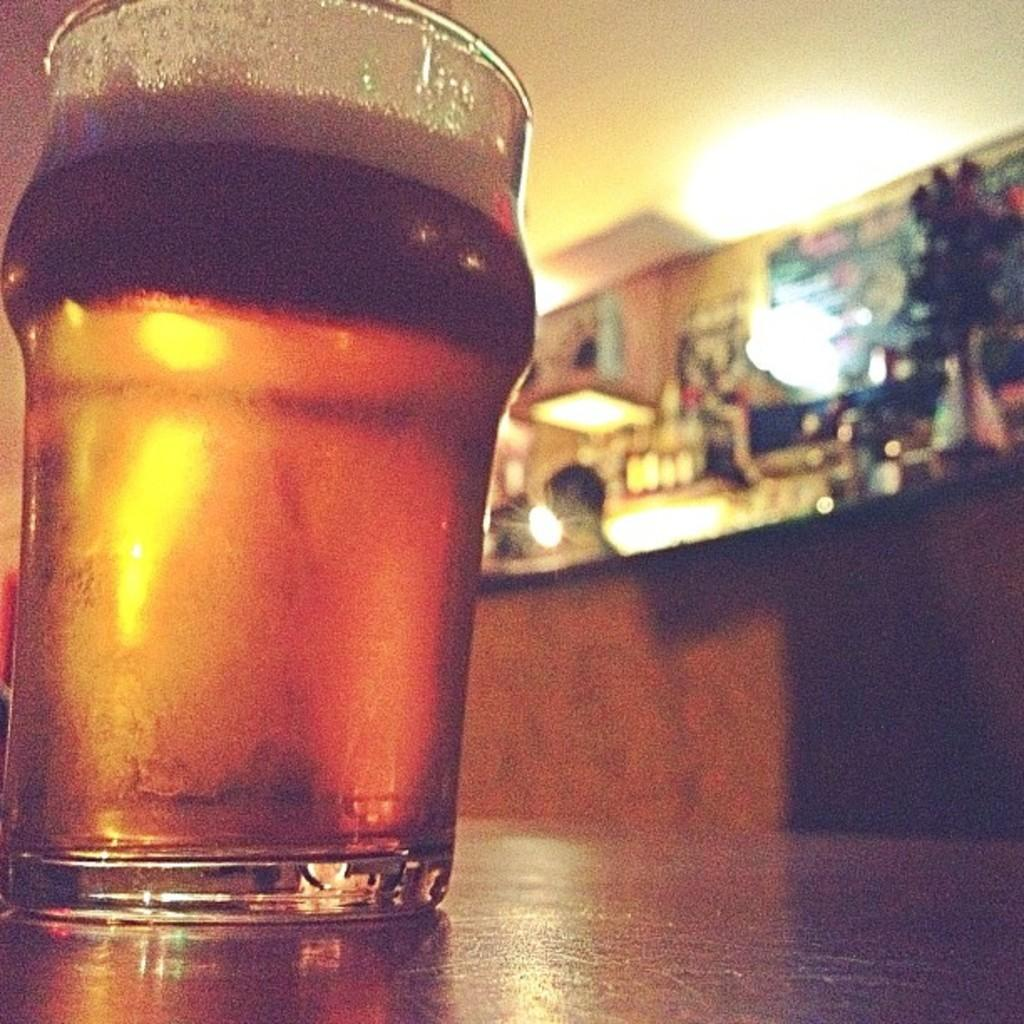What is on the surface in the image? There is a glass on the surface in the image. What can be seen in the background of the image? There is a wall, lights, a flower pot, and objects on a table visible in the background of the image. How many girls are holding soda cans in the image? There are no girls or soda cans present in the image. 